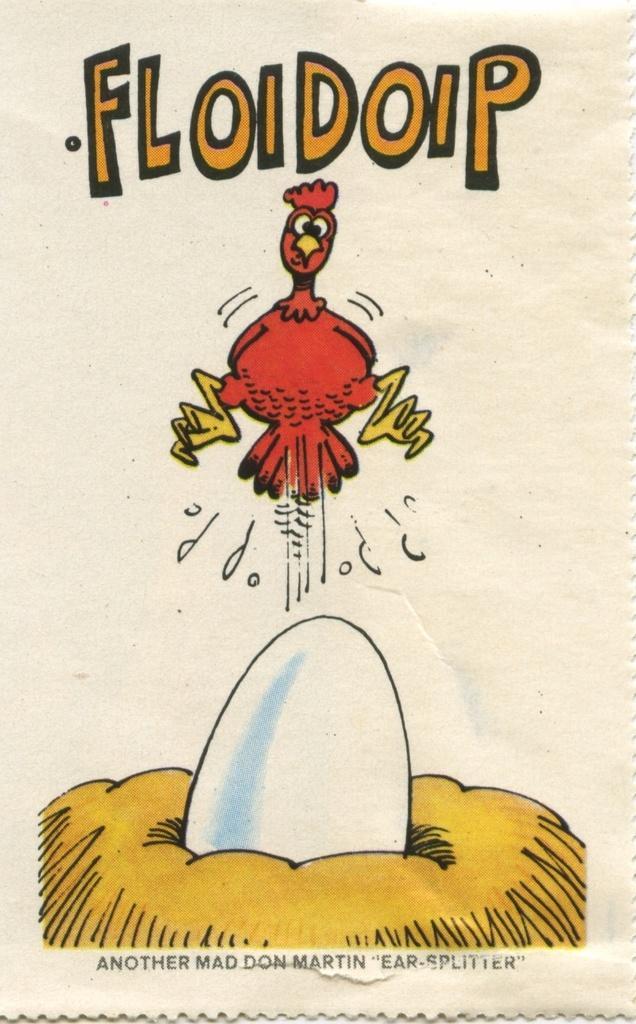Please provide a concise description of this image. In this picture there is a poster. In the center I can see the cartoon image of hen. At the bottom I can see the cartoon image of the egg on the net. 